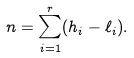<formula> <loc_0><loc_0><loc_500><loc_500>n = \sum _ { i = 1 } ^ { r } ( h _ { i } - \ell _ { i } ) .</formula> 